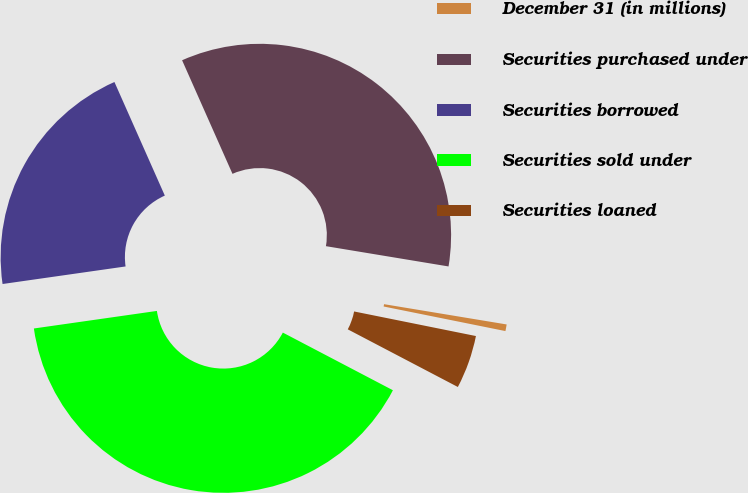Convert chart to OTSL. <chart><loc_0><loc_0><loc_500><loc_500><pie_chart><fcel>December 31 (in millions)<fcel>Securities purchased under<fcel>Securities borrowed<fcel>Securities sold under<fcel>Securities loaned<nl><fcel>0.56%<fcel>34.25%<fcel>20.61%<fcel>40.06%<fcel>4.51%<nl></chart> 